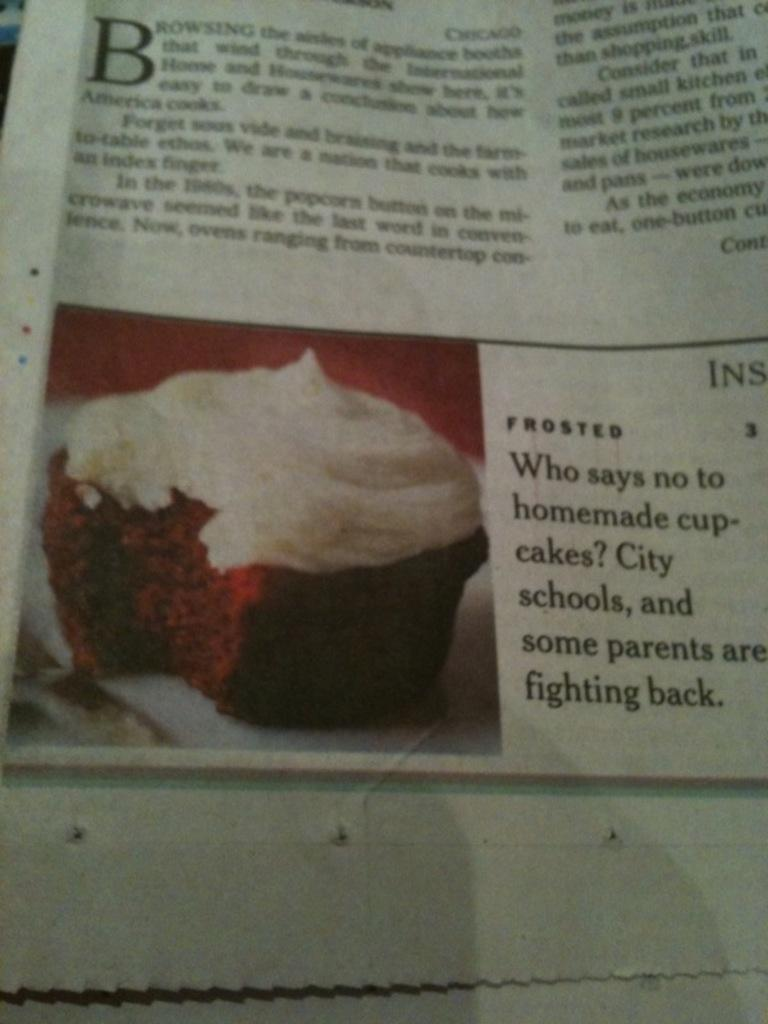Provide a one-sentence caption for the provided image. A newspaper article claims that schools and some parents do not like cupcakes. 